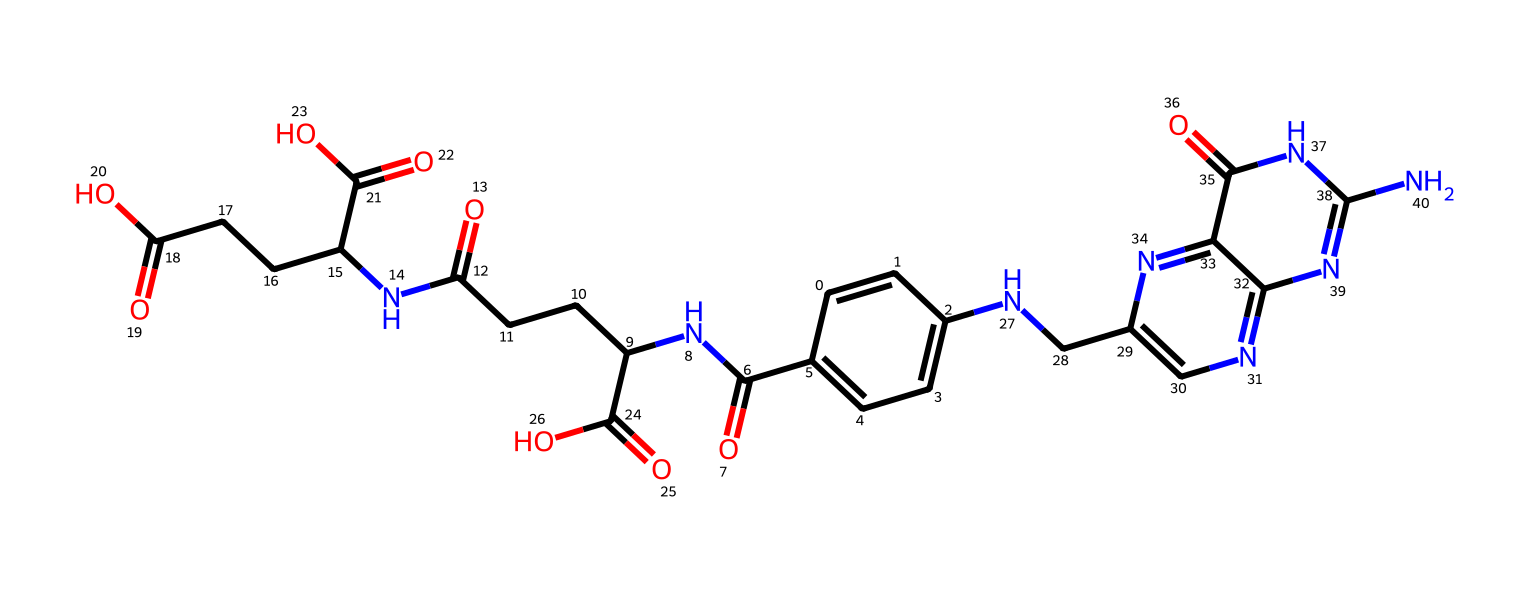what is the total number of carbon atoms in folic acid? The SMILES representation indicates the number of carbon (C) atoms by every 'C' mentioned. When counted, there are 19 carbon atoms in total.
Answer: 19 how many nitrogen atoms are present in the structure? By looking at the SMILES representation, the nitrogen (N) atoms can be identified by the 'N' symbols. There are 6 nitrogen atoms in the entire structure.
Answer: 6 what functional groups can you identify in folic acid? Folic acid exhibits functional groups such as amides (due to C(=O)NC), carboxyl groups (due to C(=O)O), and imines (indicated by the nitrogen's bonding structure).
Answer: amide, carboxyl, imine what type of bonding predominates in folic acid? The predominant type of bonding in folic acid involves covalent bonds between carbon and other atoms (C, N, O). This is due to the non-metal elements involved, which generally form covalent bonds.
Answer: covalent how many rings are present in the chemical structure of folic acid? The structure includes two fused rings (indicated by the cyclic structure in the SMILES), specifically a pteridine ring and a bicyclic structure. There are 2 rings in total.
Answer: 2 what role do the nitrogen atoms play in the folic acid structure? The nitrogen atoms in folic acid primarily contribute to its biological activity by participating in hydrogen bonding, impacting its solubility and ability to interact with enzymes and receptors.
Answer: biological activity 